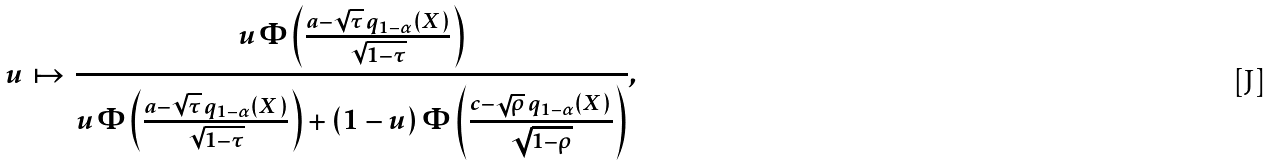Convert formula to latex. <formula><loc_0><loc_0><loc_500><loc_500>u \, \mapsto \, \frac { u \, \Phi \left ( \frac { a - \sqrt { \tau } \, q _ { 1 - \alpha } ( X ) } { \sqrt { 1 - \tau } } \right ) } { u \, \Phi \left ( \frac { a - \sqrt { \tau } \, q _ { 1 - \alpha } ( X ) } { \sqrt { 1 - \tau } } \right ) + ( 1 - u ) \, \Phi \left ( \frac { c - \sqrt { \rho } \, q _ { 1 - \alpha } ( X ) } { \sqrt { 1 - \rho } } \right ) } ,</formula> 